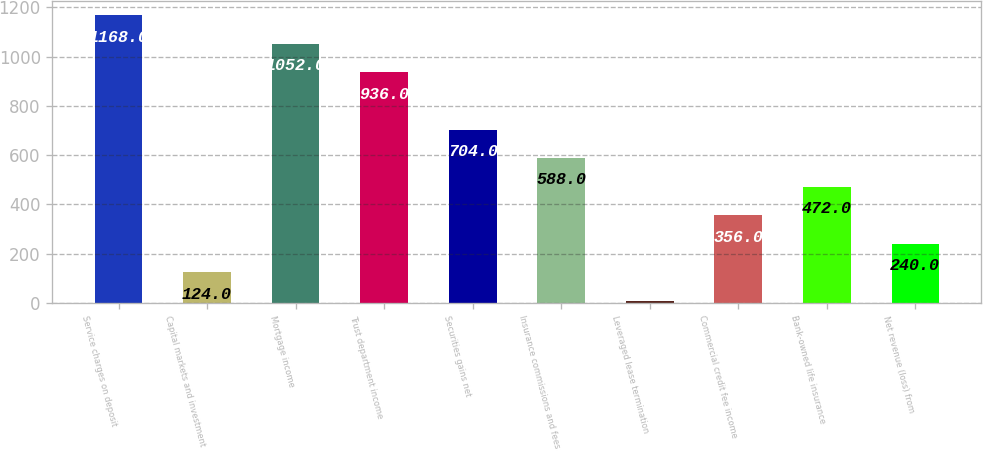<chart> <loc_0><loc_0><loc_500><loc_500><bar_chart><fcel>Service charges on deposit<fcel>Capital markets and investment<fcel>Mortgage income<fcel>Trust department income<fcel>Securities gains net<fcel>Insurance commissions and fees<fcel>Leveraged lease termination<fcel>Commercial credit fee income<fcel>Bank-owned life insurance<fcel>Net revenue (loss) from<nl><fcel>1168<fcel>124<fcel>1052<fcel>936<fcel>704<fcel>588<fcel>8<fcel>356<fcel>472<fcel>240<nl></chart> 